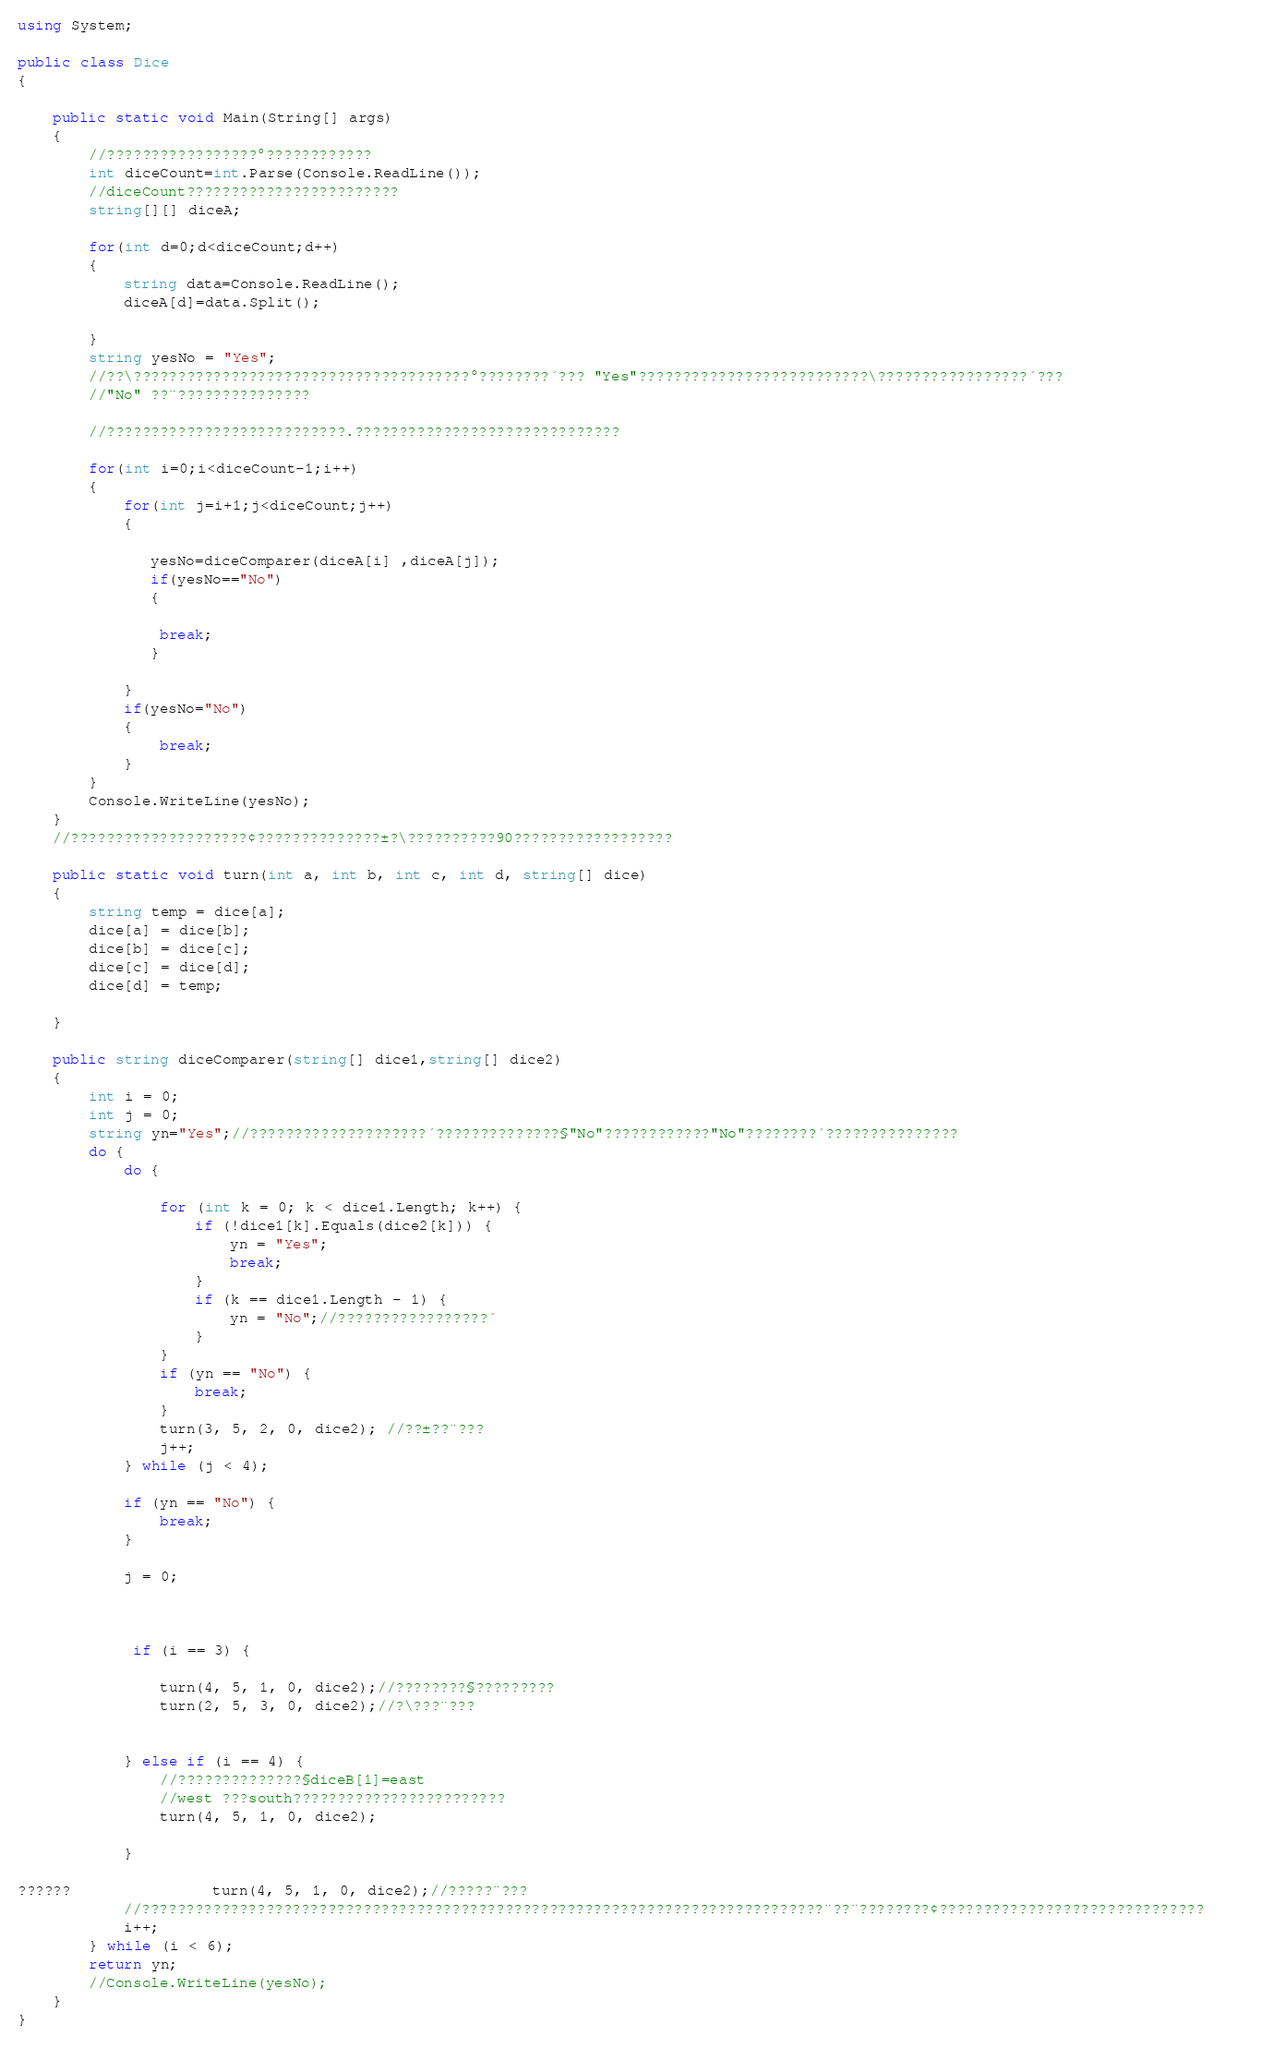<code> <loc_0><loc_0><loc_500><loc_500><_C#_>using System;

public class Dice
{

	public static void Main(String[] args)
	{
		//?????????????????°????????????
		int diceCount=int.Parse(Console.ReadLine());
		//diceCount????????????????????????
		string[][] diceA;
		
		for(int d=0;d<diceCount;d++)
		{   
			string data=Console.ReadLine();
			diceA[d]=data.Split();

		}
		string yesNo = "Yes";
		//??\??????????????????????????????????????°????????´??? "Yes"??????????????????????????\?????????????????´???
		//"No" ??¨???????????????
     	
		//???????????????????????????.??????????????????????????????
		
		for(int i=0;i<diceCount-1;i++)
		{
			for(int j=i+1;j<diceCount;j++)
			{
			    		
		       yesNo=diceComparer(diceA[i] ,diceA[j]);
		       if(yesNo=="No")
		       {
		       
		       	break;
		       }
		       
			}
			if(yesNo="No")
			{
				break;
			}
		}
		Console.WriteLine(yesNo);
	}
	//????????????????????¢??????????????±?\??????????90??????????????????

	public static void turn(int a, int b, int c, int d, string[] dice)
	{
		string temp = dice[a];
		dice[a] = dice[b];
		dice[b] = dice[c];
		dice[c] = dice[d];
		dice[d] = temp;
            
	}
	
	public string diceComparer(string[] dice1,string[] dice2)
	{
		int i = 0;
		int j = 0;
		string yn="Yes";//????????????????????´??????????????§"No"????????????"No"????????´???????????????
		do {
			do {
                  
				for (int k = 0; k < dice1.Length; k++) {
					if (!dice1[k].Equals(dice2[k])) {
						yn = "Yes";
						break;
					}
					if (k == dice1.Length - 1) {
						yn = "No";//?????????????????´
					}
				}
				if (yn == "No") {
					break;
				}
				turn(3, 5, 2, 0, dice2); //??±??¨???                  
				j++;
			} while (j < 4);

			if (yn == "No") {
				break;
			}
				
			j = 0;
				
		
			
			 if (i == 3) {
                   
				turn(4, 5, 1, 0, dice2);//????????§?????????
				turn(2, 5, 3, 0, dice2);//?\???¨???
				
					
			} else if (i == 4) {
				//??????????????§diceB[1]=east
				//west ???south????????????????????????                   
				turn(4, 5, 1, 0, dice2);  
			
			}
			
??????				turn(4, 5, 1, 0, dice2);//?????¨???
			//?????????????????????????????????????????????????????????????????????????????¨??¨????????¢??????????????????????????????		
			i++;
		} while (i < 6);
		return yn;
		//Console.WriteLine(yesNo);
	}
}</code> 